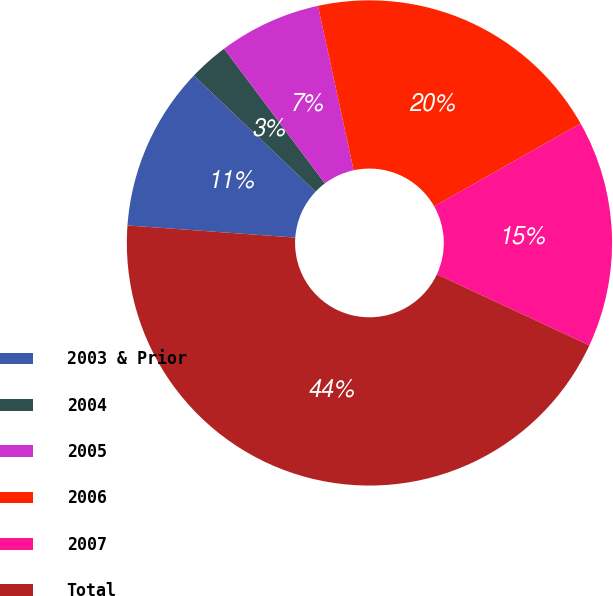<chart> <loc_0><loc_0><loc_500><loc_500><pie_chart><fcel>2003 & Prior<fcel>2004<fcel>2005<fcel>2006<fcel>2007<fcel>Total<nl><fcel>10.97%<fcel>2.66%<fcel>6.82%<fcel>20.21%<fcel>15.13%<fcel>44.21%<nl></chart> 